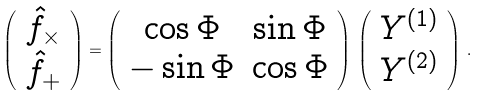<formula> <loc_0><loc_0><loc_500><loc_500>\left ( \begin{array} { c } \hat { f } _ { \times } \\ \hat { f } _ { + } \end{array} \right ) = \left ( \begin{array} { c c } \cos \Phi & \sin \Phi \\ - \sin \Phi & \cos \Phi \end{array} \right ) \, \left ( \begin{array} { c } Y ^ { ( 1 ) } \\ Y ^ { ( 2 ) } \end{array} \right ) \, . \</formula> 